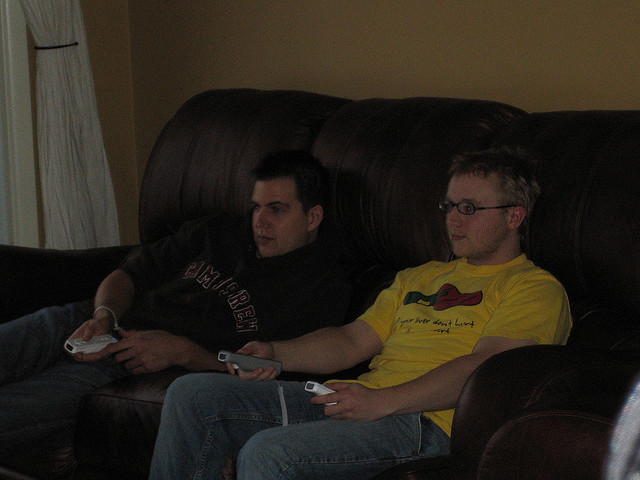<image>What fruit is pictured on the man's shirt? I don't know what fruit is pictured on the man's shirt. There might be none. What is this person's favorite baseball team? I don't know what this person's favorite baseball team is. It could be any team. What fruit is pictured on the man's shirt? I don't know what fruit is pictured on the man's shirt. It is not clear from the given answers. What is this person's favorite baseball team? It is ambiguous what this person's favorite baseball team is. It could be 'red sox', 'indians', 'cardinals', 'mariners', 'giants', or 'yankees'. 